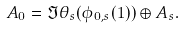<formula> <loc_0><loc_0><loc_500><loc_500>A _ { 0 } = \Im \theta _ { s } ( \phi _ { 0 , s } ( 1 ) ) \oplus A _ { s } .</formula> 